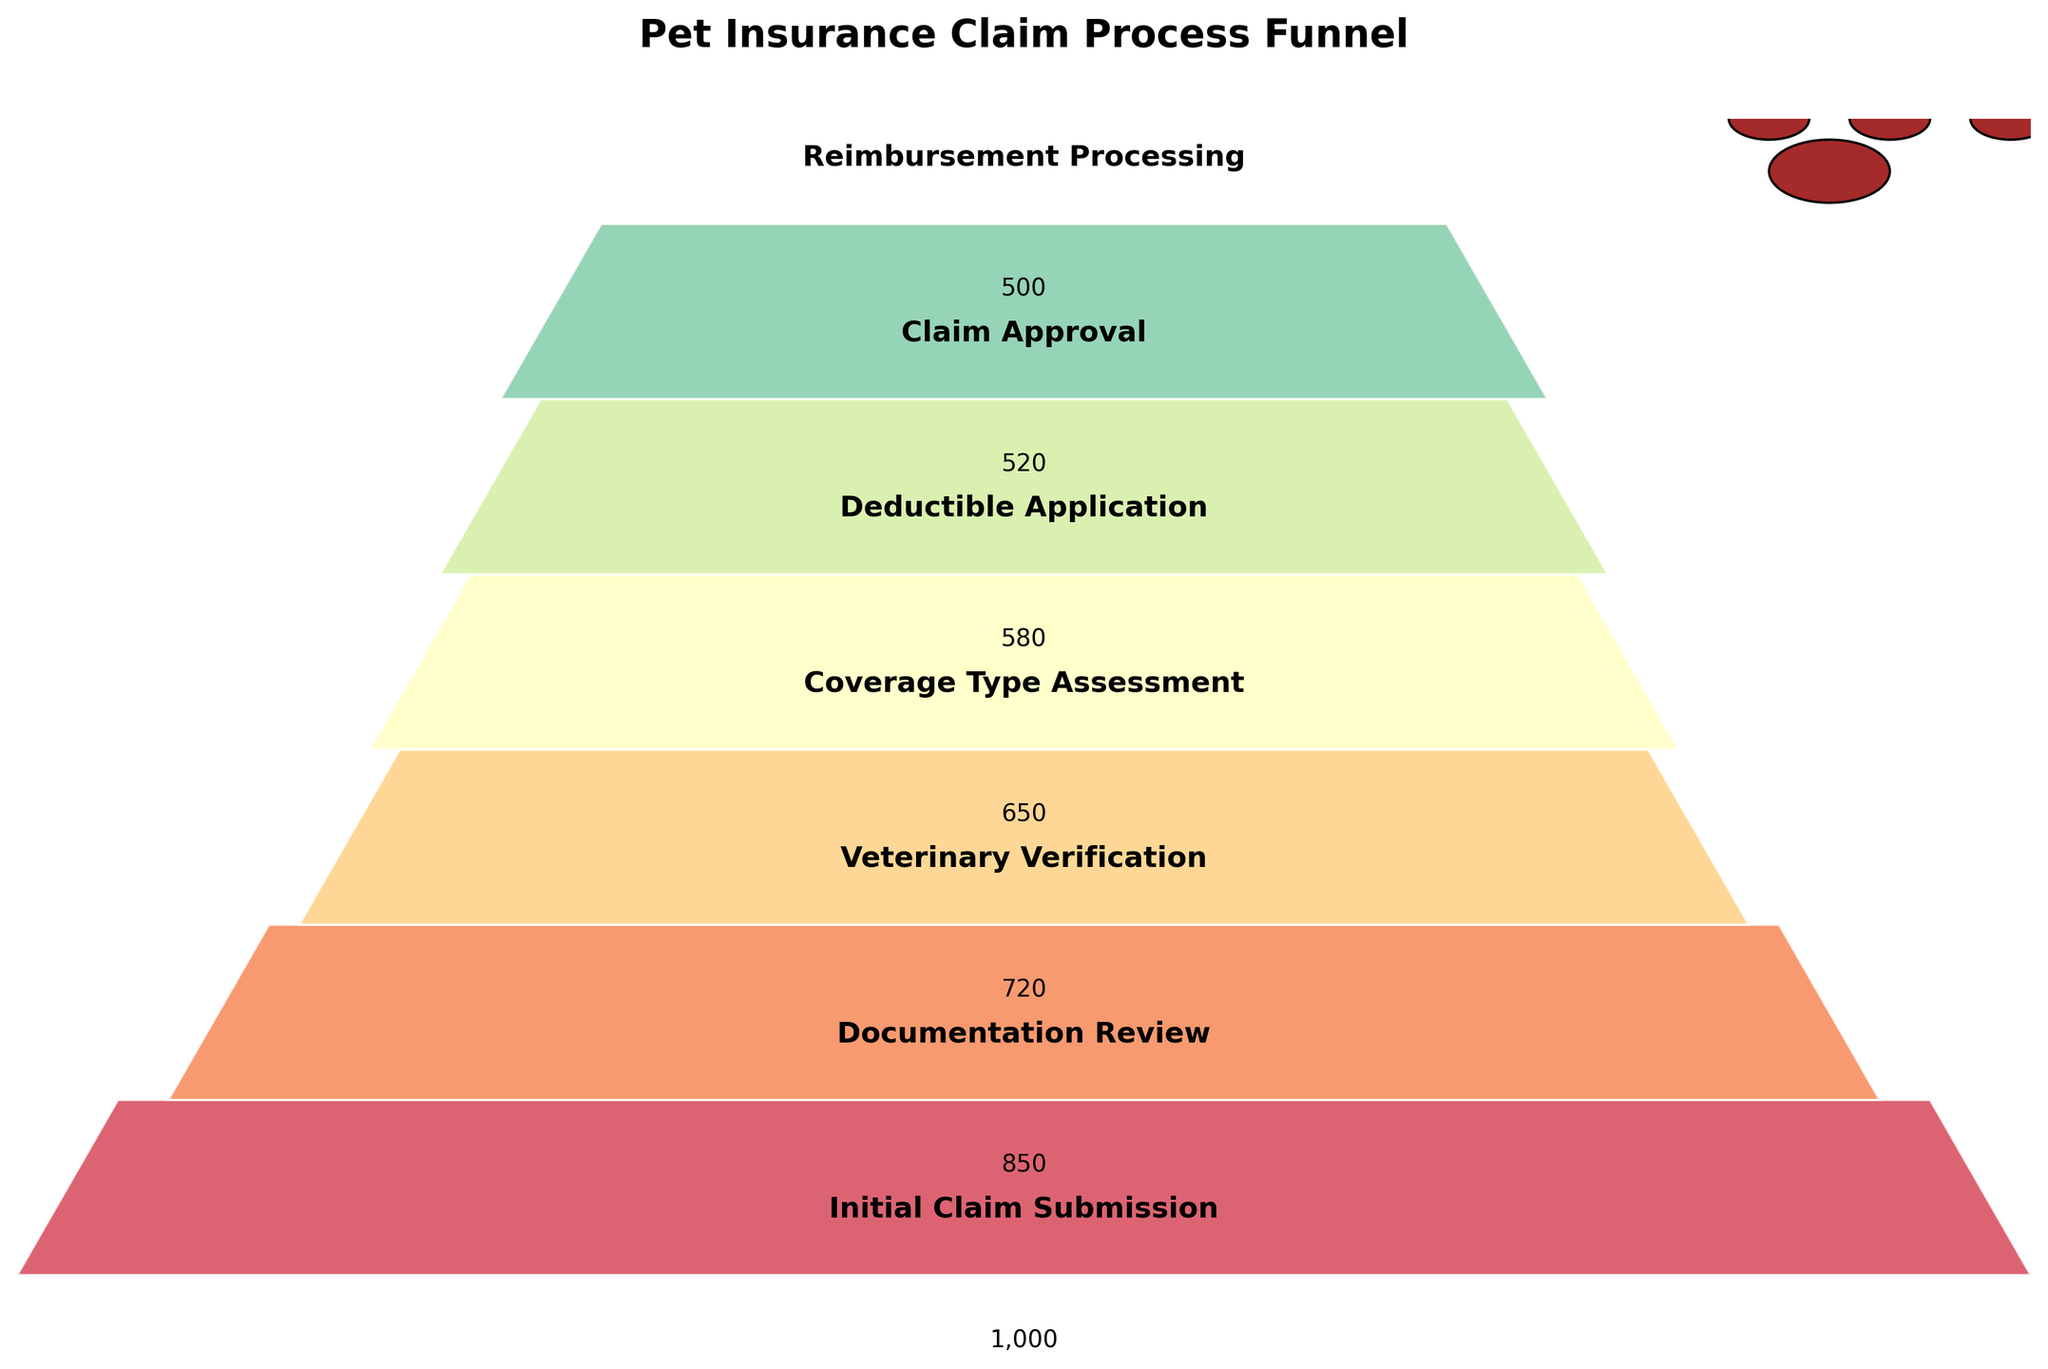What is the title of the Funnel Chart? The chart clearly indicates the title at the top center.
Answer: Pet Insurance Claim Process Funnel How many claims were initially submitted? The top stage of the funnel will show this information clearly along with the corresponding number.
Answer: 1000 Which stage has the highest number of claims? By observing the width and position of each stage, we can see the stage with the widest bar.
Answer: Initial Claim Submission How many claims are lost from the Veterinary Verification to the Coverage Type Assessment stage? Subtract the number of claims in the Coverage Type Assessment stage from the Veterinary Verification stage. 720 - 650 = 70
Answer: 70 What is the total drop in the number of claims from the Initial Claim Submission stage to the Documentation Review stage? Subtract the number of claims in the Documentation Review stage from the Initial Claim Submission stage. 1000 - 850 = 150
Answer: 150 At which stage does the number of claims drop below 600 for the first time? Look at the stages consecutively and find the first stage where the claims count is less than 600.
Answer: Deductible Application What is the final stage shown in the funnel chart and how many claims reach it? Locate the last stage at the bottom of the funnel and note the corresponding number of claims.
Answer: Reimbursement Processing, 500 How does the number of claims change from the Deductible Application stage to the Claim Approval stage? Compare the number of claims in both stages. Subtract the number of claims in Claim Approval from Deductible Application. 580 - 520 = 60
Answer: 60 What percentage of the initial claims are approved? Divide the number of claims at the Claim Approval stage by the Initial Claim Submission, and multiply by 100. (520 / 1000) * 100 = 52%
Answer: 52% Which stage experiences the greatest drop in claims, and what is the numerical difference? Identify the two consecutive stages with the biggest difference in claim numbers by comparing all stages.
Answer: Initial Claim Submission to Documentation Review, 150 